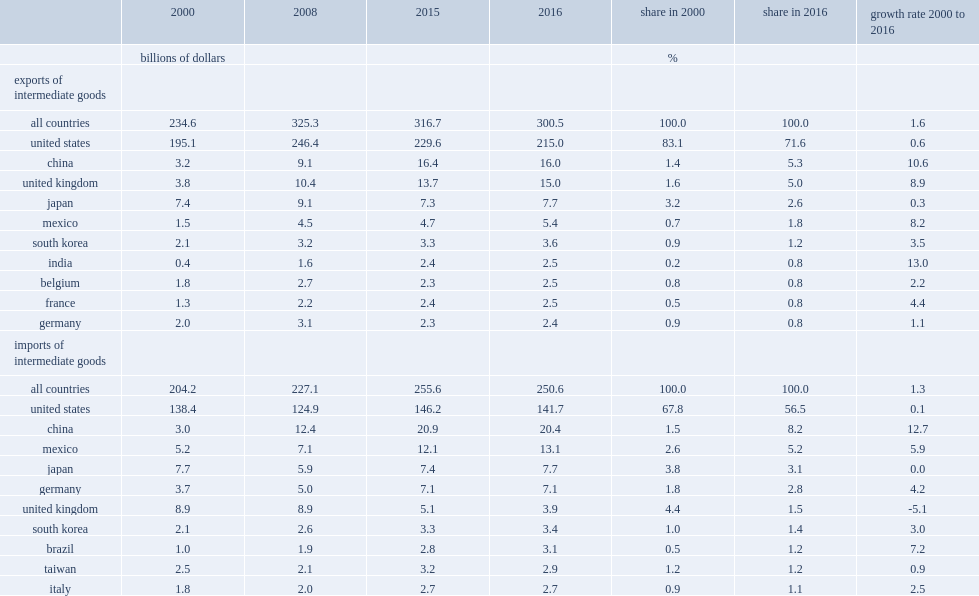What was the proportion of intermediate imports were sourced from the united states in 2016? 56.5. What was the declines in the share of intermediate imports sourced from the united states over the period 2000 to 2016? 11.3. What was the proportion of intermediate imports were from china in 2016? 8.2. What was the proportion of intermediate imports were from mexico in 2016? 5.2. What was the proportion of intermediate imports were from japan in 2016? 3.1. What was the proportion of intermediate imports were from germany in 2016? 2.8. What was the percentage of total intermediate goods imports in 2000 were from china? 1.5. What was the percentage of total intermediate goods imports in 2000 were from mexico? 2.6. Which country has negative average growth rate of intermediate imports from the u.k. over the period 2000 to 2016? United kingdom. Parse the full table. {'header': ['', '2000', '2008', '2015', '2016', 'share in 2000', 'share in 2016', 'growth rate 2000 to 2016'], 'rows': [['', 'billions of dollars', '', '', '', '%', '', ''], ['exports of intermediate goods', '', '', '', '', '', '', ''], ['all countries', '234.6', '325.3', '316.7', '300.5', '100.0', '100.0', '1.6'], ['united states', '195.1', '246.4', '229.6', '215.0', '83.1', '71.6', '0.6'], ['china', '3.2', '9.1', '16.4', '16.0', '1.4', '5.3', '10.6'], ['united kingdom', '3.8', '10.4', '13.7', '15.0', '1.6', '5.0', '8.9'], ['japan', '7.4', '9.1', '7.3', '7.7', '3.2', '2.6', '0.3'], ['mexico', '1.5', '4.5', '4.7', '5.4', '0.7', '1.8', '8.2'], ['south korea', '2.1', '3.2', '3.3', '3.6', '0.9', '1.2', '3.5'], ['india', '0.4', '1.6', '2.4', '2.5', '0.2', '0.8', '13.0'], ['belgium', '1.8', '2.7', '2.3', '2.5', '0.8', '0.8', '2.2'], ['france', '1.3', '2.2', '2.4', '2.5', '0.5', '0.8', '4.4'], ['germany', '2.0', '3.1', '2.3', '2.4', '0.9', '0.8', '1.1'], ['imports of intermediate goods', '', '', '', '', '', '', ''], ['all countries', '204.2', '227.1', '255.6', '250.6', '100.0', '100.0', '1.3'], ['united states', '138.4', '124.9', '146.2', '141.7', '67.8', '56.5', '0.1'], ['china', '3.0', '12.4', '20.9', '20.4', '1.5', '8.2', '12.7'], ['mexico', '5.2', '7.1', '12.1', '13.1', '2.6', '5.2', '5.9'], ['japan', '7.7', '5.9', '7.4', '7.7', '3.8', '3.1', '0.0'], ['germany', '3.7', '5.0', '7.1', '7.1', '1.8', '2.8', '4.2'], ['united kingdom', '8.9', '8.9', '5.1', '3.9', '4.4', '1.5', '-5.1'], ['south korea', '2.1', '2.6', '3.3', '3.4', '1.0', '1.4', '3.0'], ['brazil', '1.0', '1.9', '2.8', '3.1', '0.5', '1.2', '7.2'], ['taiwan', '2.5', '2.1', '3.2', '2.9', '1.2', '1.2', '0.9'], ['italy', '1.8', '2.0', '2.7', '2.7', '0.9', '1.1', '2.5']]} 